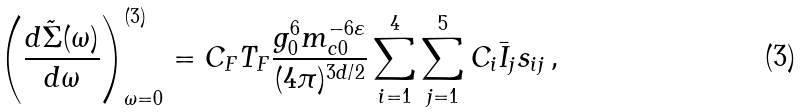Convert formula to latex. <formula><loc_0><loc_0><loc_500><loc_500>\left ( \frac { d \tilde { \Sigma } ( \omega ) } { d \omega } \right ) ^ { ( 3 ) } _ { \omega = 0 } = C _ { F } T _ { F } \frac { g _ { 0 } ^ { 6 } m _ { c 0 } ^ { - 6 \varepsilon } } { ( 4 \pi ) ^ { 3 d / 2 } } \sum _ { i = 1 } ^ { 4 } \sum _ { j = 1 } ^ { 5 } C _ { i } \bar { I } _ { j } s _ { i j } \, ,</formula> 